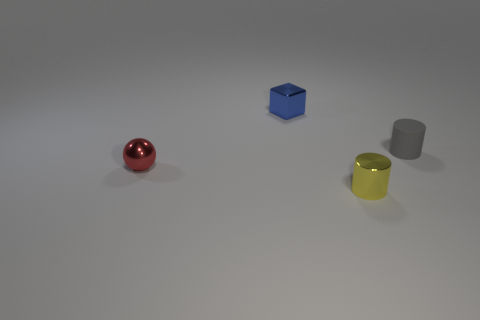Are there any other things that are the same material as the tiny gray object?
Ensure brevity in your answer.  No. Does the thing on the right side of the yellow cylinder have the same shape as the tiny object that is in front of the tiny red thing?
Provide a short and direct response. Yes. There is a thing in front of the tiny red ball; how big is it?
Make the answer very short. Small. Is the number of small red things greater than the number of small blue cylinders?
Your answer should be compact. Yes. Is the number of tiny metallic objects that are behind the red shiny ball greater than the number of small shiny balls behind the tiny yellow metal thing?
Offer a terse response. No. What is the size of the object that is on the left side of the gray object and behind the red metal sphere?
Offer a terse response. Small. What number of rubber cylinders have the same size as the blue cube?
Your answer should be compact. 1. There is a small thing that is to the right of the yellow metallic object; is it the same shape as the tiny yellow thing?
Provide a succinct answer. Yes. Is the number of red metallic spheres behind the red metallic sphere less than the number of small yellow matte blocks?
Give a very brief answer. No. Is the shape of the gray matte thing the same as the metal thing that is right of the tiny shiny block?
Your response must be concise. Yes. 